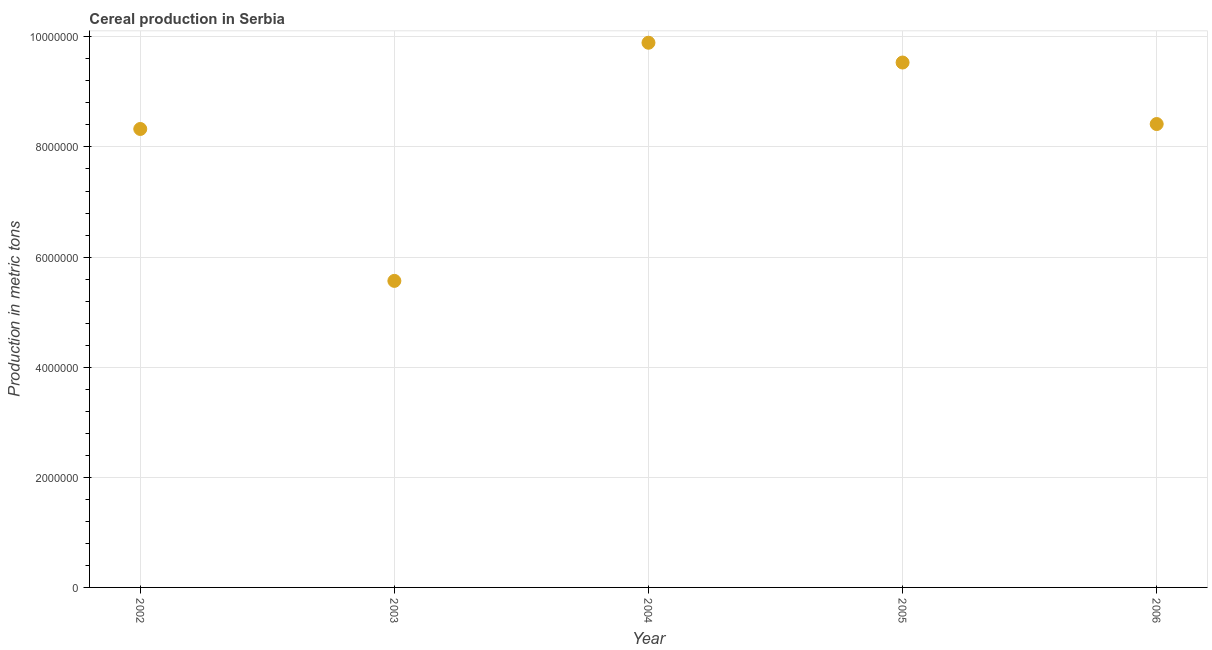What is the cereal production in 2006?
Your answer should be very brief. 8.42e+06. Across all years, what is the maximum cereal production?
Make the answer very short. 9.89e+06. Across all years, what is the minimum cereal production?
Ensure brevity in your answer.  5.57e+06. In which year was the cereal production minimum?
Offer a terse response. 2003. What is the sum of the cereal production?
Keep it short and to the point. 4.17e+07. What is the difference between the cereal production in 2002 and 2006?
Offer a terse response. -8.97e+04. What is the average cereal production per year?
Your response must be concise. 8.35e+06. What is the median cereal production?
Offer a terse response. 8.42e+06. What is the ratio of the cereal production in 2002 to that in 2004?
Your response must be concise. 0.84. Is the cereal production in 2004 less than that in 2005?
Offer a terse response. No. Is the difference between the cereal production in 2003 and 2006 greater than the difference between any two years?
Keep it short and to the point. No. What is the difference between the highest and the second highest cereal production?
Ensure brevity in your answer.  3.60e+05. Is the sum of the cereal production in 2003 and 2004 greater than the maximum cereal production across all years?
Offer a terse response. Yes. What is the difference between the highest and the lowest cereal production?
Provide a succinct answer. 4.33e+06. In how many years, is the cereal production greater than the average cereal production taken over all years?
Your answer should be compact. 3. How many dotlines are there?
Your answer should be compact. 1. How many years are there in the graph?
Your response must be concise. 5. Does the graph contain grids?
Ensure brevity in your answer.  Yes. What is the title of the graph?
Make the answer very short. Cereal production in Serbia. What is the label or title of the Y-axis?
Your answer should be very brief. Production in metric tons. What is the Production in metric tons in 2002?
Offer a very short reply. 8.33e+06. What is the Production in metric tons in 2003?
Make the answer very short. 5.57e+06. What is the Production in metric tons in 2004?
Offer a terse response. 9.89e+06. What is the Production in metric tons in 2005?
Provide a succinct answer. 9.53e+06. What is the Production in metric tons in 2006?
Your answer should be very brief. 8.42e+06. What is the difference between the Production in metric tons in 2002 and 2003?
Offer a terse response. 2.76e+06. What is the difference between the Production in metric tons in 2002 and 2004?
Provide a succinct answer. -1.57e+06. What is the difference between the Production in metric tons in 2002 and 2005?
Your answer should be compact. -1.21e+06. What is the difference between the Production in metric tons in 2002 and 2006?
Offer a terse response. -8.97e+04. What is the difference between the Production in metric tons in 2003 and 2004?
Your answer should be very brief. -4.33e+06. What is the difference between the Production in metric tons in 2003 and 2005?
Your answer should be very brief. -3.97e+06. What is the difference between the Production in metric tons in 2003 and 2006?
Provide a succinct answer. -2.85e+06. What is the difference between the Production in metric tons in 2004 and 2005?
Your answer should be compact. 3.60e+05. What is the difference between the Production in metric tons in 2004 and 2006?
Ensure brevity in your answer.  1.48e+06. What is the difference between the Production in metric tons in 2005 and 2006?
Provide a short and direct response. 1.12e+06. What is the ratio of the Production in metric tons in 2002 to that in 2003?
Make the answer very short. 1.5. What is the ratio of the Production in metric tons in 2002 to that in 2004?
Your answer should be compact. 0.84. What is the ratio of the Production in metric tons in 2002 to that in 2005?
Ensure brevity in your answer.  0.87. What is the ratio of the Production in metric tons in 2003 to that in 2004?
Give a very brief answer. 0.56. What is the ratio of the Production in metric tons in 2003 to that in 2005?
Offer a terse response. 0.58. What is the ratio of the Production in metric tons in 2003 to that in 2006?
Your answer should be very brief. 0.66. What is the ratio of the Production in metric tons in 2004 to that in 2005?
Keep it short and to the point. 1.04. What is the ratio of the Production in metric tons in 2004 to that in 2006?
Give a very brief answer. 1.18. What is the ratio of the Production in metric tons in 2005 to that in 2006?
Offer a terse response. 1.13. 